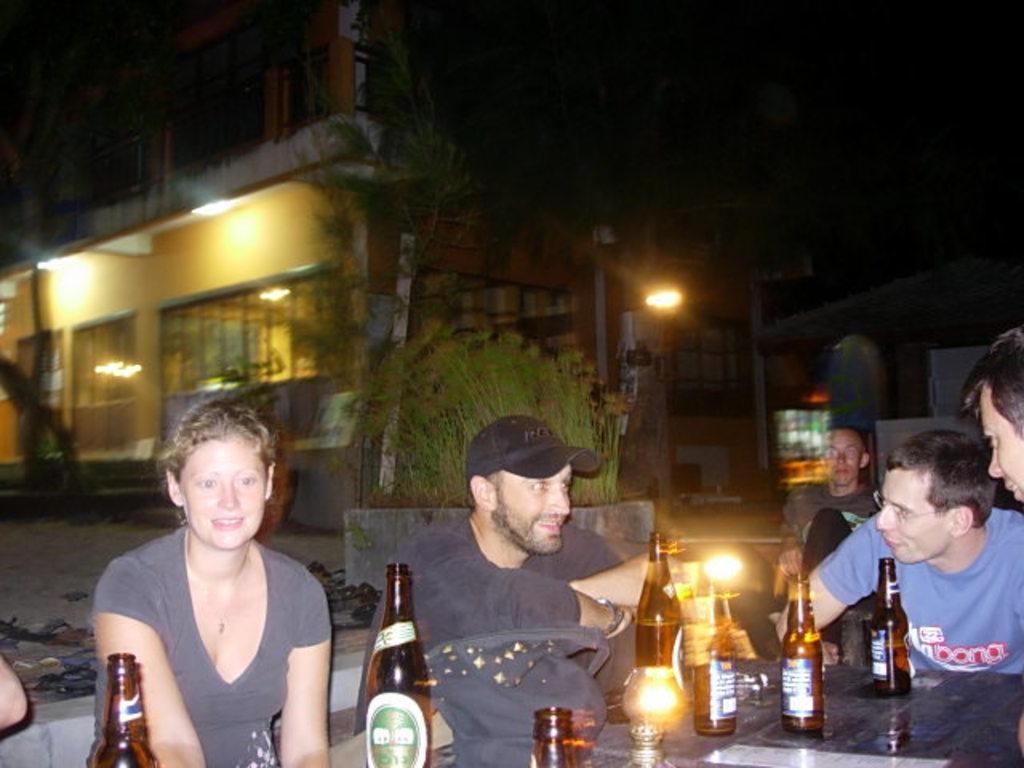Please provide a concise description of this image. In this image there are group of people sitting in chair ,and on table there are group of wine bottles,glasses on table , and at back ground there is building, plants, light. 